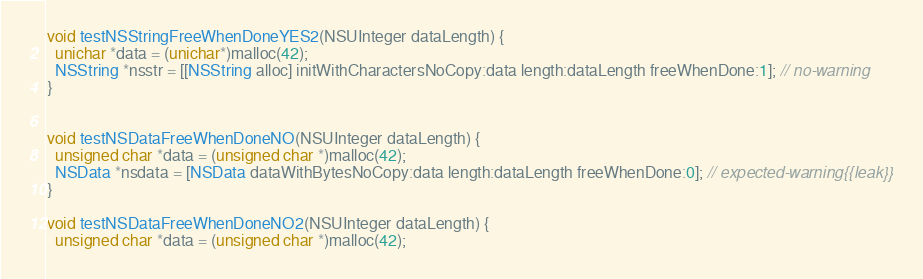<code> <loc_0><loc_0><loc_500><loc_500><_ObjectiveC_>
void testNSStringFreeWhenDoneYES2(NSUInteger dataLength) {
  unichar *data = (unichar*)malloc(42);
  NSString *nsstr = [[NSString alloc] initWithCharactersNoCopy:data length:dataLength freeWhenDone:1]; // no-warning
}


void testNSDataFreeWhenDoneNO(NSUInteger dataLength) {
  unsigned char *data = (unsigned char *)malloc(42);
  NSData *nsdata = [NSData dataWithBytesNoCopy:data length:dataLength freeWhenDone:0]; // expected-warning{{leak}}
}

void testNSDataFreeWhenDoneNO2(NSUInteger dataLength) {
  unsigned char *data = (unsigned char *)malloc(42);</code> 